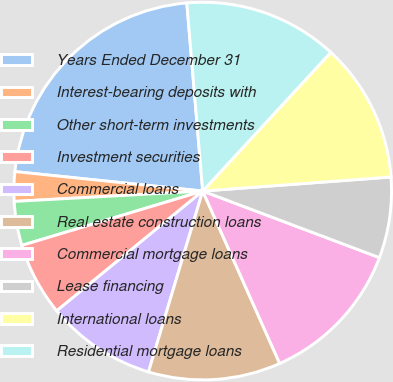<chart> <loc_0><loc_0><loc_500><loc_500><pie_chart><fcel>Years Ended December 31<fcel>Interest-bearing deposits with<fcel>Other short-term investments<fcel>Investment securities<fcel>Commercial loans<fcel>Real estate construction loans<fcel>Commercial mortgage loans<fcel>Lease financing<fcel>International loans<fcel>Residential mortgage loans<nl><fcel>22.01%<fcel>2.52%<fcel>3.77%<fcel>6.29%<fcel>9.43%<fcel>11.32%<fcel>12.58%<fcel>6.92%<fcel>11.95%<fcel>13.21%<nl></chart> 